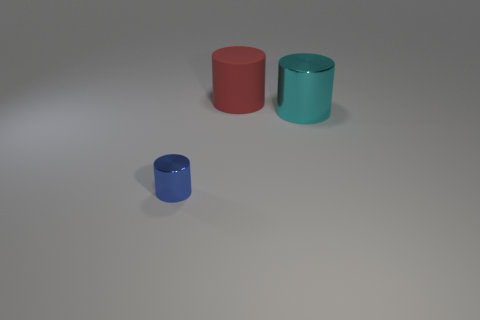How many objects are either red rubber cylinders behind the tiny metal cylinder or cylinders that are in front of the rubber cylinder?
Offer a very short reply. 3. There is a cyan object; is it the same shape as the metallic object on the left side of the big cyan cylinder?
Provide a succinct answer. Yes. What number of other objects are the same shape as the big matte object?
Offer a terse response. 2. What number of objects are big things or big gray balls?
Offer a terse response. 2. Are there any other things that have the same size as the blue cylinder?
Make the answer very short. No. What is the shape of the thing that is behind the metallic cylinder that is right of the blue shiny object?
Your answer should be compact. Cylinder. Is the number of big red rubber objects less than the number of metal objects?
Make the answer very short. Yes. What is the size of the thing that is both on the left side of the large cyan cylinder and in front of the red matte thing?
Ensure brevity in your answer.  Small. Is the size of the cyan metallic cylinder the same as the red matte thing?
Your answer should be very brief. Yes. What number of blue things are in front of the tiny blue metal cylinder?
Offer a very short reply. 0. 